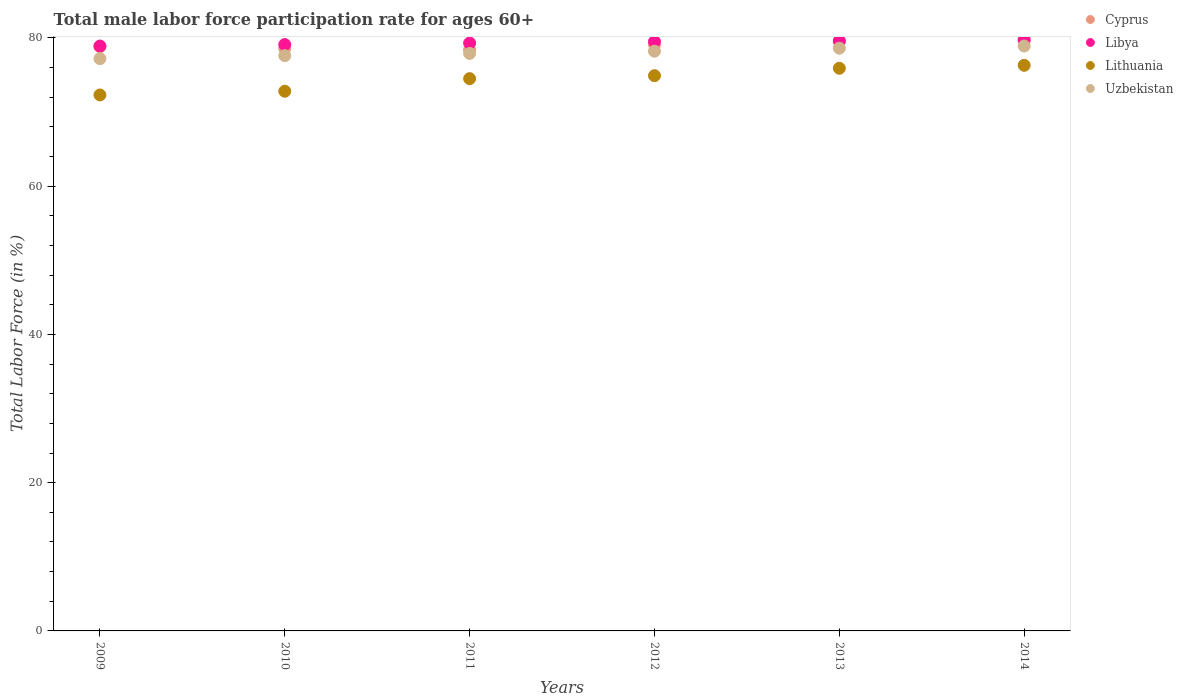Is the number of dotlines equal to the number of legend labels?
Provide a succinct answer. Yes. What is the male labor force participation rate in Lithuania in 2013?
Your answer should be very brief. 75.9. Across all years, what is the maximum male labor force participation rate in Cyprus?
Ensure brevity in your answer.  79.8. Across all years, what is the minimum male labor force participation rate in Cyprus?
Offer a very short reply. 78.4. What is the total male labor force participation rate in Lithuania in the graph?
Give a very brief answer. 446.7. What is the difference between the male labor force participation rate in Uzbekistan in 2011 and that in 2012?
Provide a succinct answer. -0.3. What is the difference between the male labor force participation rate in Lithuania in 2012 and the male labor force participation rate in Libya in 2009?
Your answer should be very brief. -4. What is the average male labor force participation rate in Libya per year?
Keep it short and to the point. 79.35. In the year 2012, what is the difference between the male labor force participation rate in Libya and male labor force participation rate in Cyprus?
Ensure brevity in your answer.  0.4. What is the ratio of the male labor force participation rate in Lithuania in 2009 to that in 2014?
Give a very brief answer. 0.95. Is the male labor force participation rate in Uzbekistan in 2010 less than that in 2014?
Offer a very short reply. Yes. What is the difference between the highest and the second highest male labor force participation rate in Libya?
Keep it short and to the point. 0.1. What is the difference between the highest and the lowest male labor force participation rate in Cyprus?
Provide a succinct answer. 1.4. In how many years, is the male labor force participation rate in Cyprus greater than the average male labor force participation rate in Cyprus taken over all years?
Provide a short and direct response. 3. Is it the case that in every year, the sum of the male labor force participation rate in Cyprus and male labor force participation rate in Libya  is greater than the sum of male labor force participation rate in Lithuania and male labor force participation rate in Uzbekistan?
Your answer should be very brief. No. How many dotlines are there?
Your answer should be very brief. 4. What is the difference between two consecutive major ticks on the Y-axis?
Your response must be concise. 20. Are the values on the major ticks of Y-axis written in scientific E-notation?
Provide a succinct answer. No. How many legend labels are there?
Offer a terse response. 4. How are the legend labels stacked?
Ensure brevity in your answer.  Vertical. What is the title of the graph?
Make the answer very short. Total male labor force participation rate for ages 60+. Does "Venezuela" appear as one of the legend labels in the graph?
Keep it short and to the point. No. What is the Total Labor Force (in %) in Cyprus in 2009?
Offer a very short reply. 78.8. What is the Total Labor Force (in %) of Libya in 2009?
Your answer should be compact. 78.9. What is the Total Labor Force (in %) in Lithuania in 2009?
Provide a short and direct response. 72.3. What is the Total Labor Force (in %) in Uzbekistan in 2009?
Provide a short and direct response. 77.2. What is the Total Labor Force (in %) in Cyprus in 2010?
Your answer should be very brief. 78.6. What is the Total Labor Force (in %) in Libya in 2010?
Your answer should be very brief. 79.1. What is the Total Labor Force (in %) in Lithuania in 2010?
Give a very brief answer. 72.8. What is the Total Labor Force (in %) in Uzbekistan in 2010?
Offer a very short reply. 77.6. What is the Total Labor Force (in %) in Cyprus in 2011?
Offer a very short reply. 78.4. What is the Total Labor Force (in %) of Libya in 2011?
Provide a succinct answer. 79.3. What is the Total Labor Force (in %) of Lithuania in 2011?
Your answer should be compact. 74.5. What is the Total Labor Force (in %) of Uzbekistan in 2011?
Give a very brief answer. 77.9. What is the Total Labor Force (in %) in Cyprus in 2012?
Offer a terse response. 79.1. What is the Total Labor Force (in %) of Libya in 2012?
Your response must be concise. 79.5. What is the Total Labor Force (in %) in Lithuania in 2012?
Your answer should be compact. 74.9. What is the Total Labor Force (in %) in Uzbekistan in 2012?
Offer a very short reply. 78.2. What is the Total Labor Force (in %) in Cyprus in 2013?
Provide a succinct answer. 79.5. What is the Total Labor Force (in %) in Libya in 2013?
Your answer should be compact. 79.6. What is the Total Labor Force (in %) in Lithuania in 2013?
Provide a succinct answer. 75.9. What is the Total Labor Force (in %) of Uzbekistan in 2013?
Provide a succinct answer. 78.6. What is the Total Labor Force (in %) in Cyprus in 2014?
Your answer should be compact. 79.8. What is the Total Labor Force (in %) of Libya in 2014?
Keep it short and to the point. 79.7. What is the Total Labor Force (in %) in Lithuania in 2014?
Offer a terse response. 76.3. What is the Total Labor Force (in %) in Uzbekistan in 2014?
Make the answer very short. 78.9. Across all years, what is the maximum Total Labor Force (in %) of Cyprus?
Ensure brevity in your answer.  79.8. Across all years, what is the maximum Total Labor Force (in %) of Libya?
Offer a terse response. 79.7. Across all years, what is the maximum Total Labor Force (in %) in Lithuania?
Your response must be concise. 76.3. Across all years, what is the maximum Total Labor Force (in %) of Uzbekistan?
Your answer should be compact. 78.9. Across all years, what is the minimum Total Labor Force (in %) in Cyprus?
Make the answer very short. 78.4. Across all years, what is the minimum Total Labor Force (in %) in Libya?
Give a very brief answer. 78.9. Across all years, what is the minimum Total Labor Force (in %) in Lithuania?
Offer a terse response. 72.3. Across all years, what is the minimum Total Labor Force (in %) in Uzbekistan?
Offer a terse response. 77.2. What is the total Total Labor Force (in %) in Cyprus in the graph?
Your answer should be compact. 474.2. What is the total Total Labor Force (in %) of Libya in the graph?
Offer a terse response. 476.1. What is the total Total Labor Force (in %) in Lithuania in the graph?
Make the answer very short. 446.7. What is the total Total Labor Force (in %) of Uzbekistan in the graph?
Ensure brevity in your answer.  468.4. What is the difference between the Total Labor Force (in %) of Lithuania in 2009 and that in 2010?
Your answer should be compact. -0.5. What is the difference between the Total Labor Force (in %) of Uzbekistan in 2009 and that in 2010?
Your answer should be very brief. -0.4. What is the difference between the Total Labor Force (in %) of Libya in 2009 and that in 2011?
Keep it short and to the point. -0.4. What is the difference between the Total Labor Force (in %) in Lithuania in 2009 and that in 2011?
Provide a succinct answer. -2.2. What is the difference between the Total Labor Force (in %) of Lithuania in 2009 and that in 2012?
Keep it short and to the point. -2.6. What is the difference between the Total Labor Force (in %) in Cyprus in 2009 and that in 2013?
Ensure brevity in your answer.  -0.7. What is the difference between the Total Labor Force (in %) in Lithuania in 2009 and that in 2013?
Your response must be concise. -3.6. What is the difference between the Total Labor Force (in %) of Lithuania in 2009 and that in 2014?
Your answer should be compact. -4. What is the difference between the Total Labor Force (in %) of Cyprus in 2010 and that in 2011?
Give a very brief answer. 0.2. What is the difference between the Total Labor Force (in %) of Libya in 2010 and that in 2011?
Your answer should be very brief. -0.2. What is the difference between the Total Labor Force (in %) of Lithuania in 2010 and that in 2011?
Your answer should be very brief. -1.7. What is the difference between the Total Labor Force (in %) of Cyprus in 2010 and that in 2012?
Your answer should be very brief. -0.5. What is the difference between the Total Labor Force (in %) in Libya in 2010 and that in 2012?
Offer a terse response. -0.4. What is the difference between the Total Labor Force (in %) of Uzbekistan in 2010 and that in 2013?
Keep it short and to the point. -1. What is the difference between the Total Labor Force (in %) of Cyprus in 2010 and that in 2014?
Ensure brevity in your answer.  -1.2. What is the difference between the Total Labor Force (in %) of Lithuania in 2011 and that in 2012?
Offer a very short reply. -0.4. What is the difference between the Total Labor Force (in %) in Cyprus in 2011 and that in 2013?
Offer a very short reply. -1.1. What is the difference between the Total Labor Force (in %) of Libya in 2011 and that in 2013?
Provide a short and direct response. -0.3. What is the difference between the Total Labor Force (in %) of Cyprus in 2011 and that in 2014?
Ensure brevity in your answer.  -1.4. What is the difference between the Total Labor Force (in %) in Libya in 2011 and that in 2014?
Your answer should be very brief. -0.4. What is the difference between the Total Labor Force (in %) in Lithuania in 2011 and that in 2014?
Provide a succinct answer. -1.8. What is the difference between the Total Labor Force (in %) of Cyprus in 2012 and that in 2013?
Your answer should be compact. -0.4. What is the difference between the Total Labor Force (in %) of Lithuania in 2012 and that in 2013?
Offer a terse response. -1. What is the difference between the Total Labor Force (in %) of Cyprus in 2012 and that in 2014?
Offer a terse response. -0.7. What is the difference between the Total Labor Force (in %) of Libya in 2012 and that in 2014?
Give a very brief answer. -0.2. What is the difference between the Total Labor Force (in %) of Uzbekistan in 2012 and that in 2014?
Your answer should be compact. -0.7. What is the difference between the Total Labor Force (in %) in Cyprus in 2013 and that in 2014?
Offer a terse response. -0.3. What is the difference between the Total Labor Force (in %) of Libya in 2013 and that in 2014?
Your response must be concise. -0.1. What is the difference between the Total Labor Force (in %) in Lithuania in 2013 and that in 2014?
Offer a very short reply. -0.4. What is the difference between the Total Labor Force (in %) in Cyprus in 2009 and the Total Labor Force (in %) in Uzbekistan in 2010?
Make the answer very short. 1.2. What is the difference between the Total Labor Force (in %) in Cyprus in 2009 and the Total Labor Force (in %) in Libya in 2011?
Ensure brevity in your answer.  -0.5. What is the difference between the Total Labor Force (in %) in Cyprus in 2009 and the Total Labor Force (in %) in Lithuania in 2011?
Offer a very short reply. 4.3. What is the difference between the Total Labor Force (in %) of Libya in 2009 and the Total Labor Force (in %) of Lithuania in 2011?
Provide a short and direct response. 4.4. What is the difference between the Total Labor Force (in %) in Libya in 2009 and the Total Labor Force (in %) in Uzbekistan in 2011?
Ensure brevity in your answer.  1. What is the difference between the Total Labor Force (in %) in Lithuania in 2009 and the Total Labor Force (in %) in Uzbekistan in 2011?
Your response must be concise. -5.6. What is the difference between the Total Labor Force (in %) of Libya in 2009 and the Total Labor Force (in %) of Uzbekistan in 2012?
Make the answer very short. 0.7. What is the difference between the Total Labor Force (in %) in Lithuania in 2009 and the Total Labor Force (in %) in Uzbekistan in 2012?
Your answer should be very brief. -5.9. What is the difference between the Total Labor Force (in %) of Libya in 2009 and the Total Labor Force (in %) of Lithuania in 2013?
Offer a terse response. 3. What is the difference between the Total Labor Force (in %) in Libya in 2009 and the Total Labor Force (in %) in Uzbekistan in 2013?
Ensure brevity in your answer.  0.3. What is the difference between the Total Labor Force (in %) in Lithuania in 2009 and the Total Labor Force (in %) in Uzbekistan in 2013?
Your response must be concise. -6.3. What is the difference between the Total Labor Force (in %) in Libya in 2009 and the Total Labor Force (in %) in Uzbekistan in 2014?
Give a very brief answer. 0. What is the difference between the Total Labor Force (in %) in Lithuania in 2009 and the Total Labor Force (in %) in Uzbekistan in 2014?
Provide a short and direct response. -6.6. What is the difference between the Total Labor Force (in %) in Cyprus in 2010 and the Total Labor Force (in %) in Uzbekistan in 2011?
Your answer should be compact. 0.7. What is the difference between the Total Labor Force (in %) in Libya in 2010 and the Total Labor Force (in %) in Lithuania in 2011?
Provide a short and direct response. 4.6. What is the difference between the Total Labor Force (in %) in Libya in 2010 and the Total Labor Force (in %) in Uzbekistan in 2011?
Your answer should be compact. 1.2. What is the difference between the Total Labor Force (in %) in Lithuania in 2010 and the Total Labor Force (in %) in Uzbekistan in 2011?
Keep it short and to the point. -5.1. What is the difference between the Total Labor Force (in %) of Cyprus in 2010 and the Total Labor Force (in %) of Libya in 2012?
Offer a terse response. -0.9. What is the difference between the Total Labor Force (in %) of Cyprus in 2010 and the Total Labor Force (in %) of Uzbekistan in 2012?
Your answer should be very brief. 0.4. What is the difference between the Total Labor Force (in %) in Libya in 2010 and the Total Labor Force (in %) in Lithuania in 2012?
Your answer should be compact. 4.2. What is the difference between the Total Labor Force (in %) of Libya in 2010 and the Total Labor Force (in %) of Uzbekistan in 2012?
Ensure brevity in your answer.  0.9. What is the difference between the Total Labor Force (in %) in Lithuania in 2010 and the Total Labor Force (in %) in Uzbekistan in 2012?
Offer a terse response. -5.4. What is the difference between the Total Labor Force (in %) of Cyprus in 2010 and the Total Labor Force (in %) of Libya in 2013?
Provide a short and direct response. -1. What is the difference between the Total Labor Force (in %) of Cyprus in 2010 and the Total Labor Force (in %) of Uzbekistan in 2013?
Provide a succinct answer. 0. What is the difference between the Total Labor Force (in %) of Lithuania in 2010 and the Total Labor Force (in %) of Uzbekistan in 2013?
Your response must be concise. -5.8. What is the difference between the Total Labor Force (in %) in Cyprus in 2010 and the Total Labor Force (in %) in Lithuania in 2014?
Offer a terse response. 2.3. What is the difference between the Total Labor Force (in %) of Cyprus in 2010 and the Total Labor Force (in %) of Uzbekistan in 2014?
Offer a very short reply. -0.3. What is the difference between the Total Labor Force (in %) in Libya in 2010 and the Total Labor Force (in %) in Lithuania in 2014?
Your answer should be compact. 2.8. What is the difference between the Total Labor Force (in %) in Cyprus in 2011 and the Total Labor Force (in %) in Lithuania in 2012?
Your answer should be compact. 3.5. What is the difference between the Total Labor Force (in %) in Libya in 2011 and the Total Labor Force (in %) in Lithuania in 2012?
Your answer should be very brief. 4.4. What is the difference between the Total Labor Force (in %) of Lithuania in 2011 and the Total Labor Force (in %) of Uzbekistan in 2012?
Provide a short and direct response. -3.7. What is the difference between the Total Labor Force (in %) in Cyprus in 2011 and the Total Labor Force (in %) in Lithuania in 2013?
Provide a short and direct response. 2.5. What is the difference between the Total Labor Force (in %) of Libya in 2011 and the Total Labor Force (in %) of Lithuania in 2013?
Offer a terse response. 3.4. What is the difference between the Total Labor Force (in %) in Libya in 2011 and the Total Labor Force (in %) in Uzbekistan in 2013?
Give a very brief answer. 0.7. What is the difference between the Total Labor Force (in %) in Cyprus in 2011 and the Total Labor Force (in %) in Lithuania in 2014?
Keep it short and to the point. 2.1. What is the difference between the Total Labor Force (in %) of Lithuania in 2011 and the Total Labor Force (in %) of Uzbekistan in 2014?
Offer a very short reply. -4.4. What is the difference between the Total Labor Force (in %) in Cyprus in 2012 and the Total Labor Force (in %) in Lithuania in 2014?
Your answer should be very brief. 2.8. What is the difference between the Total Labor Force (in %) of Cyprus in 2012 and the Total Labor Force (in %) of Uzbekistan in 2014?
Your answer should be compact. 0.2. What is the difference between the Total Labor Force (in %) of Libya in 2012 and the Total Labor Force (in %) of Uzbekistan in 2014?
Your answer should be very brief. 0.6. What is the difference between the Total Labor Force (in %) in Cyprus in 2013 and the Total Labor Force (in %) in Libya in 2014?
Your answer should be compact. -0.2. What is the difference between the Total Labor Force (in %) in Cyprus in 2013 and the Total Labor Force (in %) in Lithuania in 2014?
Offer a very short reply. 3.2. What is the difference between the Total Labor Force (in %) of Cyprus in 2013 and the Total Labor Force (in %) of Uzbekistan in 2014?
Give a very brief answer. 0.6. What is the average Total Labor Force (in %) in Cyprus per year?
Offer a terse response. 79.03. What is the average Total Labor Force (in %) in Libya per year?
Your answer should be compact. 79.35. What is the average Total Labor Force (in %) of Lithuania per year?
Provide a succinct answer. 74.45. What is the average Total Labor Force (in %) in Uzbekistan per year?
Make the answer very short. 78.07. In the year 2009, what is the difference between the Total Labor Force (in %) of Cyprus and Total Labor Force (in %) of Lithuania?
Provide a succinct answer. 6.5. In the year 2009, what is the difference between the Total Labor Force (in %) of Libya and Total Labor Force (in %) of Lithuania?
Your answer should be compact. 6.6. In the year 2009, what is the difference between the Total Labor Force (in %) of Libya and Total Labor Force (in %) of Uzbekistan?
Ensure brevity in your answer.  1.7. In the year 2009, what is the difference between the Total Labor Force (in %) in Lithuania and Total Labor Force (in %) in Uzbekistan?
Offer a very short reply. -4.9. In the year 2010, what is the difference between the Total Labor Force (in %) of Cyprus and Total Labor Force (in %) of Libya?
Offer a terse response. -0.5. In the year 2010, what is the difference between the Total Labor Force (in %) of Cyprus and Total Labor Force (in %) of Lithuania?
Provide a short and direct response. 5.8. In the year 2010, what is the difference between the Total Labor Force (in %) in Libya and Total Labor Force (in %) in Lithuania?
Your answer should be very brief. 6.3. In the year 2010, what is the difference between the Total Labor Force (in %) in Lithuania and Total Labor Force (in %) in Uzbekistan?
Keep it short and to the point. -4.8. In the year 2011, what is the difference between the Total Labor Force (in %) of Cyprus and Total Labor Force (in %) of Libya?
Your answer should be very brief. -0.9. In the year 2011, what is the difference between the Total Labor Force (in %) of Cyprus and Total Labor Force (in %) of Uzbekistan?
Your answer should be very brief. 0.5. In the year 2011, what is the difference between the Total Labor Force (in %) in Lithuania and Total Labor Force (in %) in Uzbekistan?
Make the answer very short. -3.4. In the year 2012, what is the difference between the Total Labor Force (in %) in Cyprus and Total Labor Force (in %) in Libya?
Your response must be concise. -0.4. In the year 2012, what is the difference between the Total Labor Force (in %) in Cyprus and Total Labor Force (in %) in Lithuania?
Give a very brief answer. 4.2. In the year 2012, what is the difference between the Total Labor Force (in %) of Libya and Total Labor Force (in %) of Lithuania?
Make the answer very short. 4.6. In the year 2013, what is the difference between the Total Labor Force (in %) of Cyprus and Total Labor Force (in %) of Libya?
Provide a short and direct response. -0.1. In the year 2013, what is the difference between the Total Labor Force (in %) of Cyprus and Total Labor Force (in %) of Uzbekistan?
Provide a succinct answer. 0.9. In the year 2013, what is the difference between the Total Labor Force (in %) of Libya and Total Labor Force (in %) of Lithuania?
Ensure brevity in your answer.  3.7. In the year 2013, what is the difference between the Total Labor Force (in %) in Libya and Total Labor Force (in %) in Uzbekistan?
Keep it short and to the point. 1. In the year 2013, what is the difference between the Total Labor Force (in %) in Lithuania and Total Labor Force (in %) in Uzbekistan?
Make the answer very short. -2.7. In the year 2014, what is the difference between the Total Labor Force (in %) in Cyprus and Total Labor Force (in %) in Libya?
Provide a succinct answer. 0.1. In the year 2014, what is the difference between the Total Labor Force (in %) in Cyprus and Total Labor Force (in %) in Uzbekistan?
Give a very brief answer. 0.9. In the year 2014, what is the difference between the Total Labor Force (in %) of Libya and Total Labor Force (in %) of Uzbekistan?
Make the answer very short. 0.8. What is the ratio of the Total Labor Force (in %) in Libya in 2009 to that in 2010?
Keep it short and to the point. 1. What is the ratio of the Total Labor Force (in %) in Lithuania in 2009 to that in 2010?
Provide a succinct answer. 0.99. What is the ratio of the Total Labor Force (in %) of Cyprus in 2009 to that in 2011?
Keep it short and to the point. 1.01. What is the ratio of the Total Labor Force (in %) of Lithuania in 2009 to that in 2011?
Make the answer very short. 0.97. What is the ratio of the Total Labor Force (in %) in Uzbekistan in 2009 to that in 2011?
Ensure brevity in your answer.  0.99. What is the ratio of the Total Labor Force (in %) in Cyprus in 2009 to that in 2012?
Provide a succinct answer. 1. What is the ratio of the Total Labor Force (in %) in Libya in 2009 to that in 2012?
Provide a short and direct response. 0.99. What is the ratio of the Total Labor Force (in %) of Lithuania in 2009 to that in 2012?
Ensure brevity in your answer.  0.97. What is the ratio of the Total Labor Force (in %) in Uzbekistan in 2009 to that in 2012?
Offer a very short reply. 0.99. What is the ratio of the Total Labor Force (in %) in Libya in 2009 to that in 2013?
Give a very brief answer. 0.99. What is the ratio of the Total Labor Force (in %) in Lithuania in 2009 to that in 2013?
Your answer should be very brief. 0.95. What is the ratio of the Total Labor Force (in %) of Uzbekistan in 2009 to that in 2013?
Keep it short and to the point. 0.98. What is the ratio of the Total Labor Force (in %) of Cyprus in 2009 to that in 2014?
Provide a succinct answer. 0.99. What is the ratio of the Total Labor Force (in %) in Lithuania in 2009 to that in 2014?
Provide a short and direct response. 0.95. What is the ratio of the Total Labor Force (in %) of Uzbekistan in 2009 to that in 2014?
Make the answer very short. 0.98. What is the ratio of the Total Labor Force (in %) in Cyprus in 2010 to that in 2011?
Provide a succinct answer. 1. What is the ratio of the Total Labor Force (in %) of Lithuania in 2010 to that in 2011?
Give a very brief answer. 0.98. What is the ratio of the Total Labor Force (in %) of Uzbekistan in 2010 to that in 2011?
Your response must be concise. 1. What is the ratio of the Total Labor Force (in %) of Cyprus in 2010 to that in 2012?
Make the answer very short. 0.99. What is the ratio of the Total Labor Force (in %) in Libya in 2010 to that in 2012?
Provide a short and direct response. 0.99. What is the ratio of the Total Labor Force (in %) in Lithuania in 2010 to that in 2012?
Your answer should be very brief. 0.97. What is the ratio of the Total Labor Force (in %) in Uzbekistan in 2010 to that in 2012?
Provide a short and direct response. 0.99. What is the ratio of the Total Labor Force (in %) in Cyprus in 2010 to that in 2013?
Offer a terse response. 0.99. What is the ratio of the Total Labor Force (in %) of Libya in 2010 to that in 2013?
Provide a short and direct response. 0.99. What is the ratio of the Total Labor Force (in %) in Lithuania in 2010 to that in 2013?
Provide a succinct answer. 0.96. What is the ratio of the Total Labor Force (in %) in Uzbekistan in 2010 to that in 2013?
Make the answer very short. 0.99. What is the ratio of the Total Labor Force (in %) of Lithuania in 2010 to that in 2014?
Your answer should be compact. 0.95. What is the ratio of the Total Labor Force (in %) of Uzbekistan in 2010 to that in 2014?
Provide a short and direct response. 0.98. What is the ratio of the Total Labor Force (in %) of Cyprus in 2011 to that in 2012?
Offer a terse response. 0.99. What is the ratio of the Total Labor Force (in %) in Libya in 2011 to that in 2012?
Your answer should be compact. 1. What is the ratio of the Total Labor Force (in %) in Cyprus in 2011 to that in 2013?
Your answer should be compact. 0.99. What is the ratio of the Total Labor Force (in %) in Lithuania in 2011 to that in 2013?
Offer a terse response. 0.98. What is the ratio of the Total Labor Force (in %) in Cyprus in 2011 to that in 2014?
Keep it short and to the point. 0.98. What is the ratio of the Total Labor Force (in %) of Libya in 2011 to that in 2014?
Your response must be concise. 0.99. What is the ratio of the Total Labor Force (in %) in Lithuania in 2011 to that in 2014?
Your answer should be compact. 0.98. What is the ratio of the Total Labor Force (in %) of Uzbekistan in 2011 to that in 2014?
Provide a short and direct response. 0.99. What is the ratio of the Total Labor Force (in %) of Cyprus in 2012 to that in 2013?
Keep it short and to the point. 0.99. What is the ratio of the Total Labor Force (in %) of Lithuania in 2012 to that in 2013?
Provide a short and direct response. 0.99. What is the ratio of the Total Labor Force (in %) of Uzbekistan in 2012 to that in 2013?
Provide a short and direct response. 0.99. What is the ratio of the Total Labor Force (in %) in Libya in 2012 to that in 2014?
Your answer should be very brief. 1. What is the ratio of the Total Labor Force (in %) of Lithuania in 2012 to that in 2014?
Your answer should be very brief. 0.98. What is the ratio of the Total Labor Force (in %) of Lithuania in 2013 to that in 2014?
Ensure brevity in your answer.  0.99. What is the ratio of the Total Labor Force (in %) in Uzbekistan in 2013 to that in 2014?
Offer a terse response. 1. What is the difference between the highest and the second highest Total Labor Force (in %) of Cyprus?
Give a very brief answer. 0.3. What is the difference between the highest and the second highest Total Labor Force (in %) of Lithuania?
Provide a short and direct response. 0.4. What is the difference between the highest and the lowest Total Labor Force (in %) of Lithuania?
Make the answer very short. 4. 